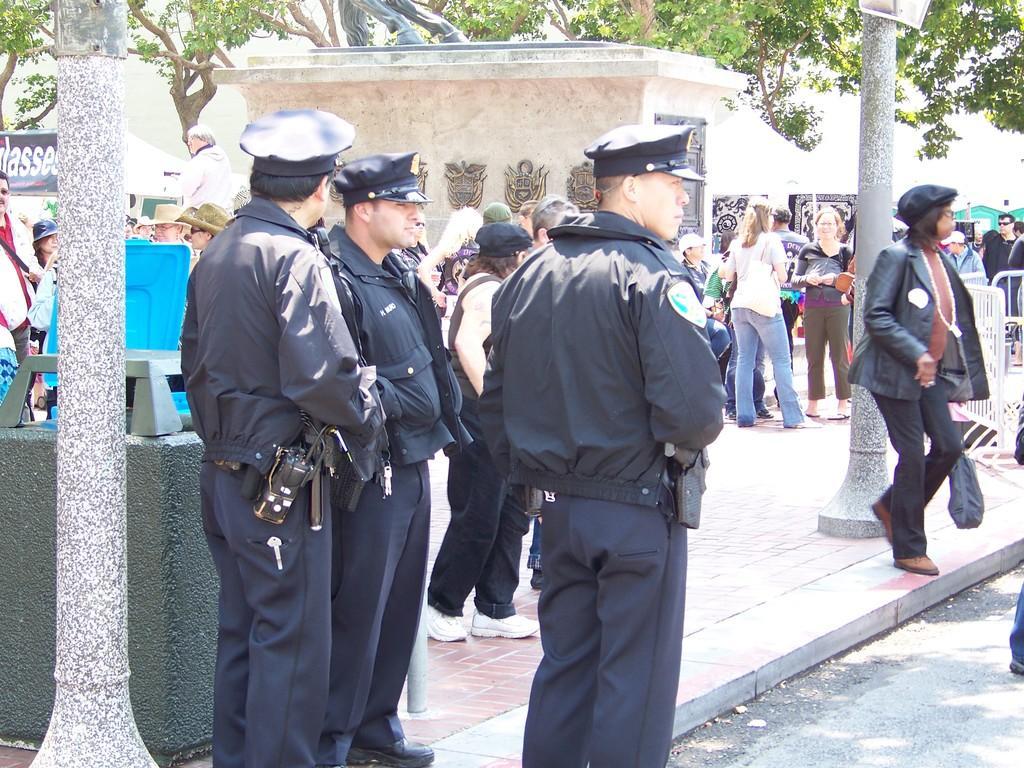Could you give a brief overview of what you see in this image? In this picture I can see some people are standing beside the road, around we can see some trees, banners, tents and some benches. 